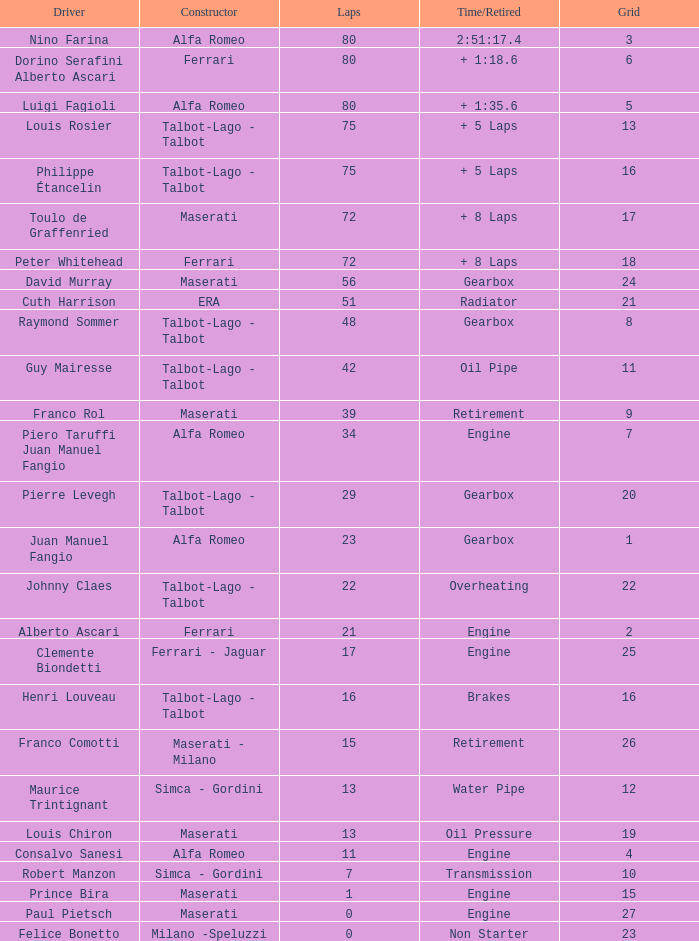In a situation where the grid is below 7, there are over 17 laps, and the time/retired is above 1:35.6, which constructor is involved? Alfa Romeo. 